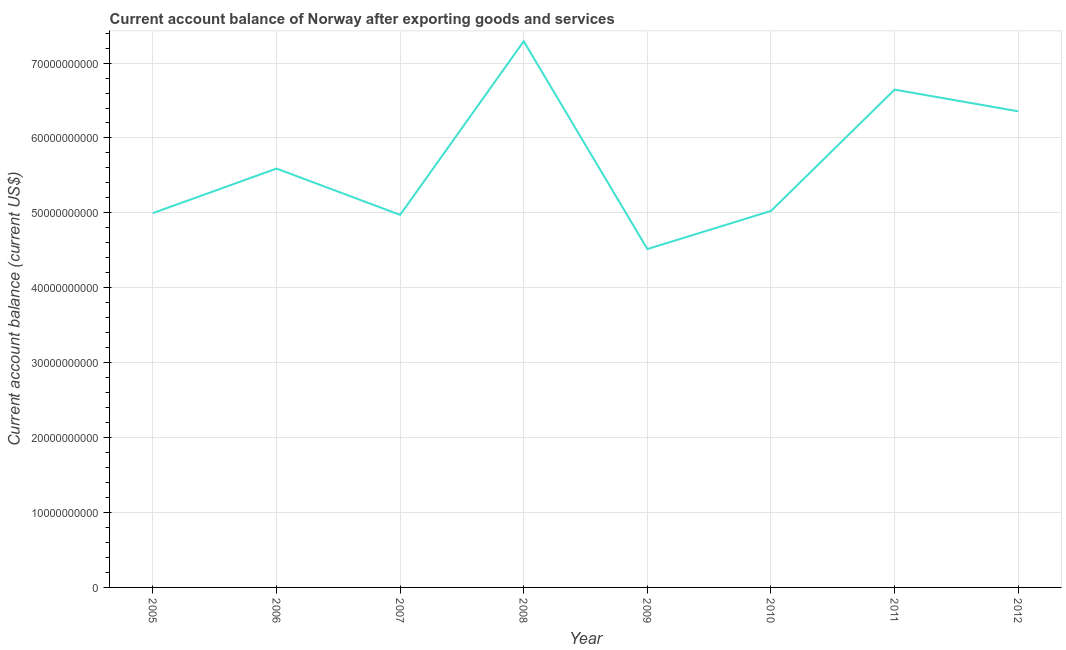What is the current account balance in 2006?
Your answer should be very brief. 5.59e+1. Across all years, what is the maximum current account balance?
Ensure brevity in your answer.  7.29e+1. Across all years, what is the minimum current account balance?
Make the answer very short. 4.52e+1. In which year was the current account balance minimum?
Your answer should be very brief. 2009. What is the sum of the current account balance?
Give a very brief answer. 4.54e+11. What is the difference between the current account balance in 2009 and 2012?
Your response must be concise. -1.84e+1. What is the average current account balance per year?
Offer a very short reply. 5.67e+1. What is the median current account balance?
Keep it short and to the point. 5.31e+1. What is the ratio of the current account balance in 2008 to that in 2011?
Provide a succinct answer. 1.1. What is the difference between the highest and the second highest current account balance?
Your answer should be very brief. 6.46e+09. Is the sum of the current account balance in 2007 and 2009 greater than the maximum current account balance across all years?
Your response must be concise. Yes. What is the difference between the highest and the lowest current account balance?
Give a very brief answer. 2.77e+1. In how many years, is the current account balance greater than the average current account balance taken over all years?
Make the answer very short. 3. Does the current account balance monotonically increase over the years?
Provide a succinct answer. No. How many years are there in the graph?
Offer a very short reply. 8. What is the title of the graph?
Provide a succinct answer. Current account balance of Norway after exporting goods and services. What is the label or title of the X-axis?
Your answer should be very brief. Year. What is the label or title of the Y-axis?
Your answer should be compact. Current account balance (current US$). What is the Current account balance (current US$) in 2005?
Ensure brevity in your answer.  5.00e+1. What is the Current account balance (current US$) of 2006?
Provide a succinct answer. 5.59e+1. What is the Current account balance (current US$) in 2007?
Your answer should be compact. 4.97e+1. What is the Current account balance (current US$) of 2008?
Make the answer very short. 7.29e+1. What is the Current account balance (current US$) of 2009?
Your answer should be compact. 4.52e+1. What is the Current account balance (current US$) of 2010?
Your response must be concise. 5.03e+1. What is the Current account balance (current US$) in 2011?
Provide a short and direct response. 6.65e+1. What is the Current account balance (current US$) of 2012?
Your answer should be compact. 6.36e+1. What is the difference between the Current account balance (current US$) in 2005 and 2006?
Keep it short and to the point. -5.95e+09. What is the difference between the Current account balance (current US$) in 2005 and 2007?
Give a very brief answer. 2.35e+08. What is the difference between the Current account balance (current US$) in 2005 and 2008?
Your answer should be compact. -2.29e+1. What is the difference between the Current account balance (current US$) in 2005 and 2009?
Keep it short and to the point. 4.80e+09. What is the difference between the Current account balance (current US$) in 2005 and 2010?
Ensure brevity in your answer.  -2.91e+08. What is the difference between the Current account balance (current US$) in 2005 and 2011?
Ensure brevity in your answer.  -1.65e+1. What is the difference between the Current account balance (current US$) in 2005 and 2012?
Give a very brief answer. -1.36e+1. What is the difference between the Current account balance (current US$) in 2006 and 2007?
Your response must be concise. 6.18e+09. What is the difference between the Current account balance (current US$) in 2006 and 2008?
Your answer should be compact. -1.70e+1. What is the difference between the Current account balance (current US$) in 2006 and 2009?
Provide a short and direct response. 1.07e+1. What is the difference between the Current account balance (current US$) in 2006 and 2010?
Keep it short and to the point. 5.65e+09. What is the difference between the Current account balance (current US$) in 2006 and 2011?
Provide a short and direct response. -1.05e+1. What is the difference between the Current account balance (current US$) in 2006 and 2012?
Make the answer very short. -7.64e+09. What is the difference between the Current account balance (current US$) in 2007 and 2008?
Give a very brief answer. -2.32e+1. What is the difference between the Current account balance (current US$) in 2007 and 2009?
Your answer should be compact. 4.56e+09. What is the difference between the Current account balance (current US$) in 2007 and 2010?
Your answer should be very brief. -5.26e+08. What is the difference between the Current account balance (current US$) in 2007 and 2011?
Provide a succinct answer. -1.67e+1. What is the difference between the Current account balance (current US$) in 2007 and 2012?
Offer a very short reply. -1.38e+1. What is the difference between the Current account balance (current US$) in 2008 and 2009?
Ensure brevity in your answer.  2.77e+1. What is the difference between the Current account balance (current US$) in 2008 and 2010?
Provide a succinct answer. 2.27e+1. What is the difference between the Current account balance (current US$) in 2008 and 2011?
Make the answer very short. 6.46e+09. What is the difference between the Current account balance (current US$) in 2008 and 2012?
Your response must be concise. 9.36e+09. What is the difference between the Current account balance (current US$) in 2009 and 2010?
Provide a short and direct response. -5.09e+09. What is the difference between the Current account balance (current US$) in 2009 and 2011?
Offer a very short reply. -2.13e+1. What is the difference between the Current account balance (current US$) in 2009 and 2012?
Your response must be concise. -1.84e+1. What is the difference between the Current account balance (current US$) in 2010 and 2011?
Offer a very short reply. -1.62e+1. What is the difference between the Current account balance (current US$) in 2010 and 2012?
Provide a succinct answer. -1.33e+1. What is the difference between the Current account balance (current US$) in 2011 and 2012?
Ensure brevity in your answer.  2.90e+09. What is the ratio of the Current account balance (current US$) in 2005 to that in 2006?
Your answer should be very brief. 0.89. What is the ratio of the Current account balance (current US$) in 2005 to that in 2007?
Ensure brevity in your answer.  1. What is the ratio of the Current account balance (current US$) in 2005 to that in 2008?
Give a very brief answer. 0.69. What is the ratio of the Current account balance (current US$) in 2005 to that in 2009?
Offer a very short reply. 1.11. What is the ratio of the Current account balance (current US$) in 2005 to that in 2010?
Provide a succinct answer. 0.99. What is the ratio of the Current account balance (current US$) in 2005 to that in 2011?
Ensure brevity in your answer.  0.75. What is the ratio of the Current account balance (current US$) in 2005 to that in 2012?
Make the answer very short. 0.79. What is the ratio of the Current account balance (current US$) in 2006 to that in 2007?
Provide a succinct answer. 1.12. What is the ratio of the Current account balance (current US$) in 2006 to that in 2008?
Provide a succinct answer. 0.77. What is the ratio of the Current account balance (current US$) in 2006 to that in 2009?
Keep it short and to the point. 1.24. What is the ratio of the Current account balance (current US$) in 2006 to that in 2010?
Make the answer very short. 1.11. What is the ratio of the Current account balance (current US$) in 2006 to that in 2011?
Your answer should be compact. 0.84. What is the ratio of the Current account balance (current US$) in 2007 to that in 2008?
Provide a succinct answer. 0.68. What is the ratio of the Current account balance (current US$) in 2007 to that in 2009?
Offer a very short reply. 1.1. What is the ratio of the Current account balance (current US$) in 2007 to that in 2010?
Provide a succinct answer. 0.99. What is the ratio of the Current account balance (current US$) in 2007 to that in 2011?
Keep it short and to the point. 0.75. What is the ratio of the Current account balance (current US$) in 2007 to that in 2012?
Offer a terse response. 0.78. What is the ratio of the Current account balance (current US$) in 2008 to that in 2009?
Offer a terse response. 1.61. What is the ratio of the Current account balance (current US$) in 2008 to that in 2010?
Your answer should be compact. 1.45. What is the ratio of the Current account balance (current US$) in 2008 to that in 2011?
Your answer should be compact. 1.1. What is the ratio of the Current account balance (current US$) in 2008 to that in 2012?
Ensure brevity in your answer.  1.15. What is the ratio of the Current account balance (current US$) in 2009 to that in 2010?
Offer a terse response. 0.9. What is the ratio of the Current account balance (current US$) in 2009 to that in 2011?
Provide a succinct answer. 0.68. What is the ratio of the Current account balance (current US$) in 2009 to that in 2012?
Offer a terse response. 0.71. What is the ratio of the Current account balance (current US$) in 2010 to that in 2011?
Offer a terse response. 0.76. What is the ratio of the Current account balance (current US$) in 2010 to that in 2012?
Your response must be concise. 0.79. What is the ratio of the Current account balance (current US$) in 2011 to that in 2012?
Give a very brief answer. 1.05. 